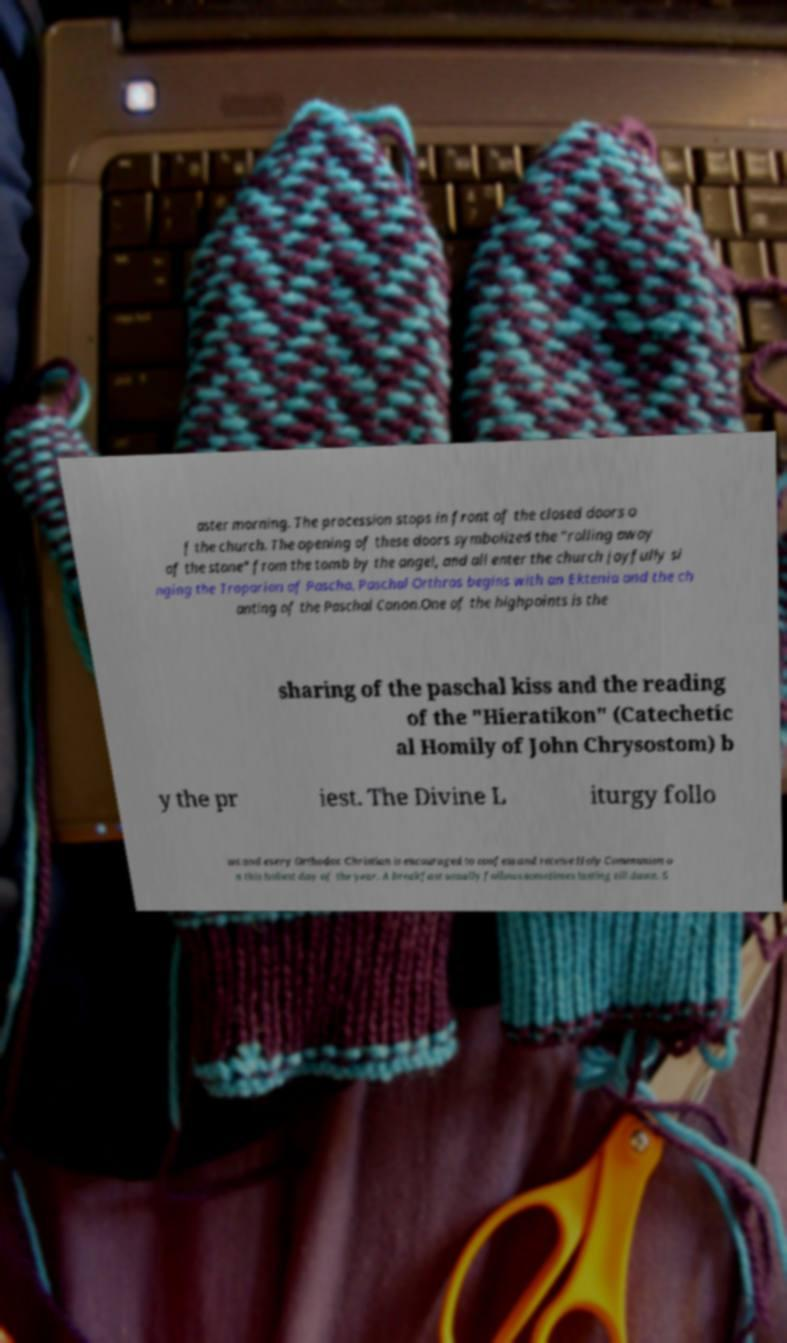Please identify and transcribe the text found in this image. aster morning. The procession stops in front of the closed doors o f the church. The opening of these doors symbolized the "rolling away of the stone" from the tomb by the angel, and all enter the church joyfully si nging the Troparion of Pascha. Paschal Orthros begins with an Ektenia and the ch anting of the Paschal Canon.One of the highpoints is the sharing of the paschal kiss and the reading of the "Hieratikon" (Catechetic al Homily of John Chrysostom) b y the pr iest. The Divine L iturgy follo ws and every Orthodox Christian is encouraged to confess and receive Holy Communion o n this holiest day of the year. A breakfast usually follows sometimes lasting till dawn. S 